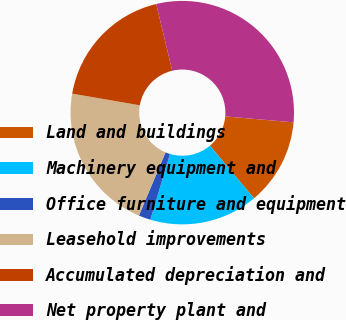<chart> <loc_0><loc_0><loc_500><loc_500><pie_chart><fcel>Land and buildings<fcel>Machinery equipment and<fcel>Office furniture and equipment<fcel>Leasehold improvements<fcel>Accumulated depreciation and<fcel>Net property plant and<nl><fcel>12.53%<fcel>15.69%<fcel>1.74%<fcel>21.37%<fcel>18.53%<fcel>30.13%<nl></chart> 